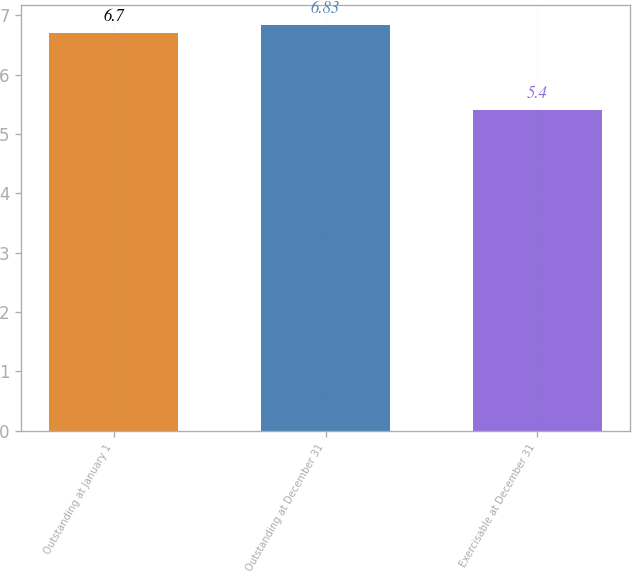<chart> <loc_0><loc_0><loc_500><loc_500><bar_chart><fcel>Outstanding at January 1<fcel>Outstanding at December 31<fcel>Exercisable at December 31<nl><fcel>6.7<fcel>6.83<fcel>5.4<nl></chart> 